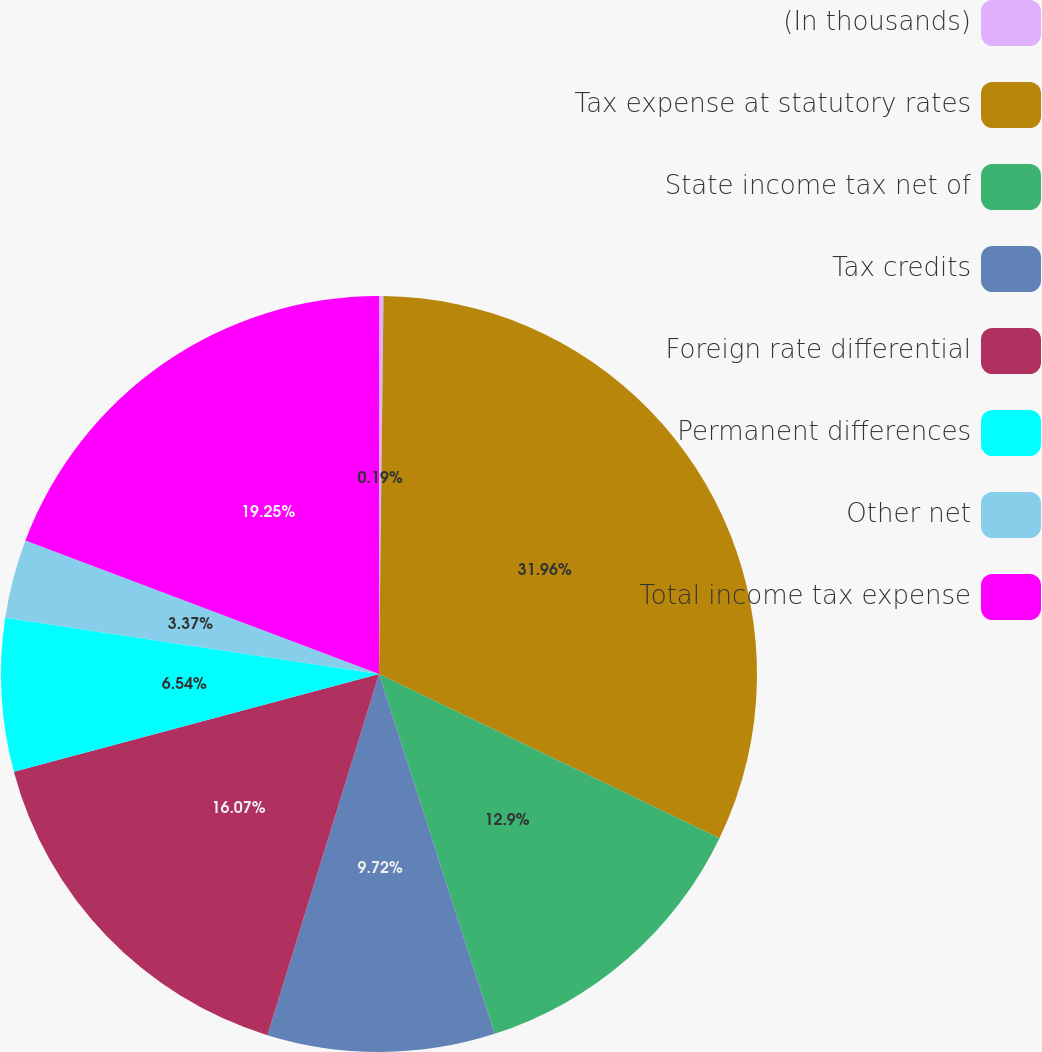Convert chart. <chart><loc_0><loc_0><loc_500><loc_500><pie_chart><fcel>(In thousands)<fcel>Tax expense at statutory rates<fcel>State income tax net of<fcel>Tax credits<fcel>Foreign rate differential<fcel>Permanent differences<fcel>Other net<fcel>Total income tax expense<nl><fcel>0.19%<fcel>31.96%<fcel>12.9%<fcel>9.72%<fcel>16.07%<fcel>6.54%<fcel>3.37%<fcel>19.25%<nl></chart> 